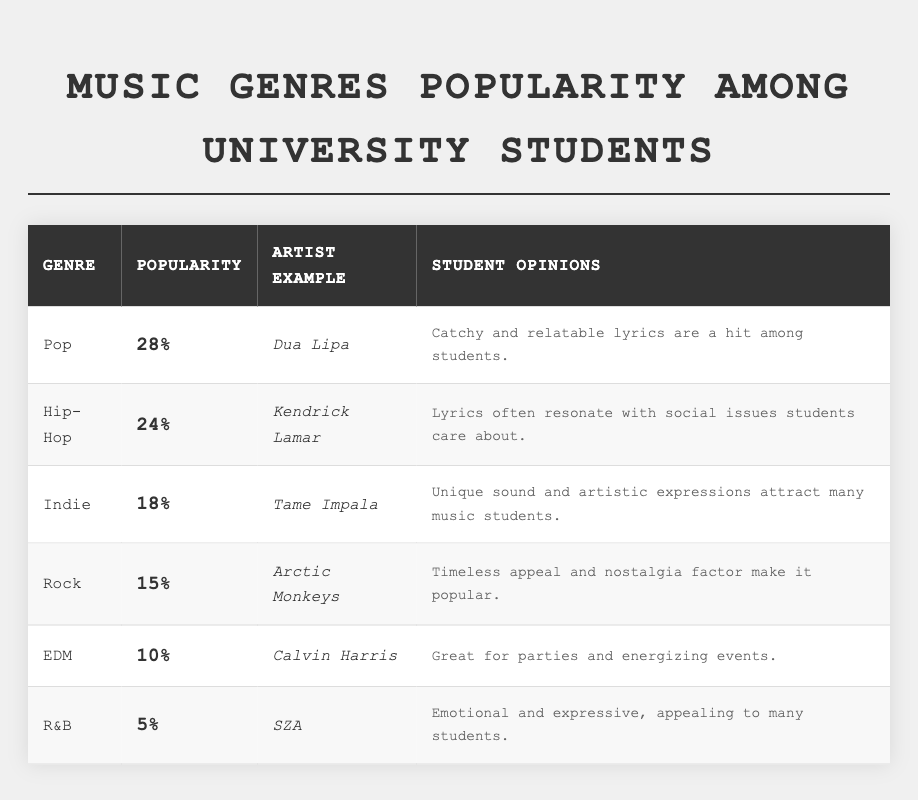What is the most popular music genre among university students? The table shows that Pop has the highest percentage of popularity at 28%.
Answer: Pop Which genre has the lowest popularity among the students? According to the table, R&B has the lowest popularity, with only 5%.
Answer: R&B What percentage of students prefer Indie music? Indie music is preferred by 18% of the students, as indicated in the table.
Answer: 18% Which artist example is associated with Rock music? The table lists Arctic Monkeys as the artist example for the Rock genre.
Answer: Arctic Monkeys If you combine the popularity of Pop and Hip-Hop, what would that be? The percentage for Pop is 28% and for Hip-Hop is 24%. Adding those together gives 28% + 24% = 52%.
Answer: 52% Is the statement "EDM is more popular than R&B" true? The table shows that EDM has a popularity of 10%, while R&B is at 5%, making the statement true.
Answer: Yes What is the percentage difference between the popularity of Hip-Hop and Rock? Hip-Hop has a popularity of 24% and Rock has 15%. The difference is 24% - 15% = 9%.
Answer: 9% Which genres have a combined popularity of more than 40%? Pop (28%) + Hip-Hop (24%) = 52%, which exceeds 40%. Other combinations like Pop + Indie (46%) also exceed 40%, while Hip-Hop + Indie (42%) does. Thus, Pop with Hip-Hop, Pop with Indie, and Hip-Hop with Indie all qualify.
Answer: Pop and Hip-Hop; Pop and Indie; Hip-Hop and Indie What genre do students find "Great for parties and energizing events"? The table states that EDM is described as "Great for parties and energizing events."
Answer: EDM Which two genres are closest in popularity percentage? Looking at the percentages, Indie (18%) and Rock (15%) are closest, with a difference of 3%.
Answer: Indie and Rock 